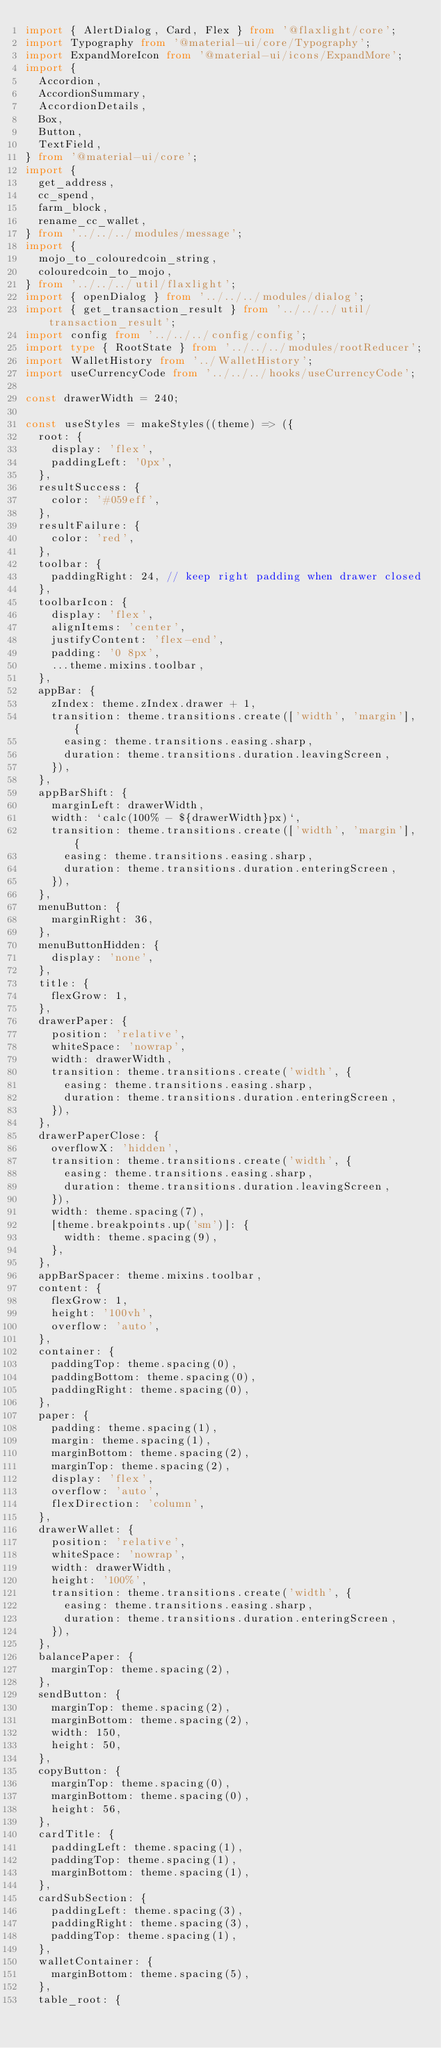Convert code to text. <code><loc_0><loc_0><loc_500><loc_500><_TypeScript_>import { AlertDialog, Card, Flex } from '@flaxlight/core';
import Typography from '@material-ui/core/Typography';
import ExpandMoreIcon from '@material-ui/icons/ExpandMore';
import {
  Accordion,
  AccordionSummary,
  AccordionDetails,
  Box,
  Button,
  TextField,
} from '@material-ui/core';
import {
  get_address,
  cc_spend,
  farm_block,
  rename_cc_wallet,
} from '../../../modules/message';
import {
  mojo_to_colouredcoin_string,
  colouredcoin_to_mojo,
} from '../../../util/flaxlight';
import { openDialog } from '../../../modules/dialog';
import { get_transaction_result } from '../../../util/transaction_result';
import config from '../../../config/config';
import type { RootState } from '../../../modules/rootReducer';
import WalletHistory from '../WalletHistory';
import useCurrencyCode from '../../../hooks/useCurrencyCode';

const drawerWidth = 240;

const useStyles = makeStyles((theme) => ({
  root: {
    display: 'flex',
    paddingLeft: '0px',
  },
  resultSuccess: {
    color: '#059eff',
  },
  resultFailure: {
    color: 'red',
  },
  toolbar: {
    paddingRight: 24, // keep right padding when drawer closed
  },
  toolbarIcon: {
    display: 'flex',
    alignItems: 'center',
    justifyContent: 'flex-end',
    padding: '0 8px',
    ...theme.mixins.toolbar,
  },
  appBar: {
    zIndex: theme.zIndex.drawer + 1,
    transition: theme.transitions.create(['width', 'margin'], {
      easing: theme.transitions.easing.sharp,
      duration: theme.transitions.duration.leavingScreen,
    }),
  },
  appBarShift: {
    marginLeft: drawerWidth,
    width: `calc(100% - ${drawerWidth}px)`,
    transition: theme.transitions.create(['width', 'margin'], {
      easing: theme.transitions.easing.sharp,
      duration: theme.transitions.duration.enteringScreen,
    }),
  },
  menuButton: {
    marginRight: 36,
  },
  menuButtonHidden: {
    display: 'none',
  },
  title: {
    flexGrow: 1,
  },
  drawerPaper: {
    position: 'relative',
    whiteSpace: 'nowrap',
    width: drawerWidth,
    transition: theme.transitions.create('width', {
      easing: theme.transitions.easing.sharp,
      duration: theme.transitions.duration.enteringScreen,
    }),
  },
  drawerPaperClose: {
    overflowX: 'hidden',
    transition: theme.transitions.create('width', {
      easing: theme.transitions.easing.sharp,
      duration: theme.transitions.duration.leavingScreen,
    }),
    width: theme.spacing(7),
    [theme.breakpoints.up('sm')]: {
      width: theme.spacing(9),
    },
  },
  appBarSpacer: theme.mixins.toolbar,
  content: {
    flexGrow: 1,
    height: '100vh',
    overflow: 'auto',
  },
  container: {
    paddingTop: theme.spacing(0),
    paddingBottom: theme.spacing(0),
    paddingRight: theme.spacing(0),
  },
  paper: {
    padding: theme.spacing(1),
    margin: theme.spacing(1),
    marginBottom: theme.spacing(2),
    marginTop: theme.spacing(2),
    display: 'flex',
    overflow: 'auto',
    flexDirection: 'column',
  },
  drawerWallet: {
    position: 'relative',
    whiteSpace: 'nowrap',
    width: drawerWidth,
    height: '100%',
    transition: theme.transitions.create('width', {
      easing: theme.transitions.easing.sharp,
      duration: theme.transitions.duration.enteringScreen,
    }),
  },
  balancePaper: {
    marginTop: theme.spacing(2),
  },
  sendButton: {
    marginTop: theme.spacing(2),
    marginBottom: theme.spacing(2),
    width: 150,
    height: 50,
  },
  copyButton: {
    marginTop: theme.spacing(0),
    marginBottom: theme.spacing(0),
    height: 56,
  },
  cardTitle: {
    paddingLeft: theme.spacing(1),
    paddingTop: theme.spacing(1),
    marginBottom: theme.spacing(1),
  },
  cardSubSection: {
    paddingLeft: theme.spacing(3),
    paddingRight: theme.spacing(3),
    paddingTop: theme.spacing(1),
  },
  walletContainer: {
    marginBottom: theme.spacing(5),
  },
  table_root: {</code> 